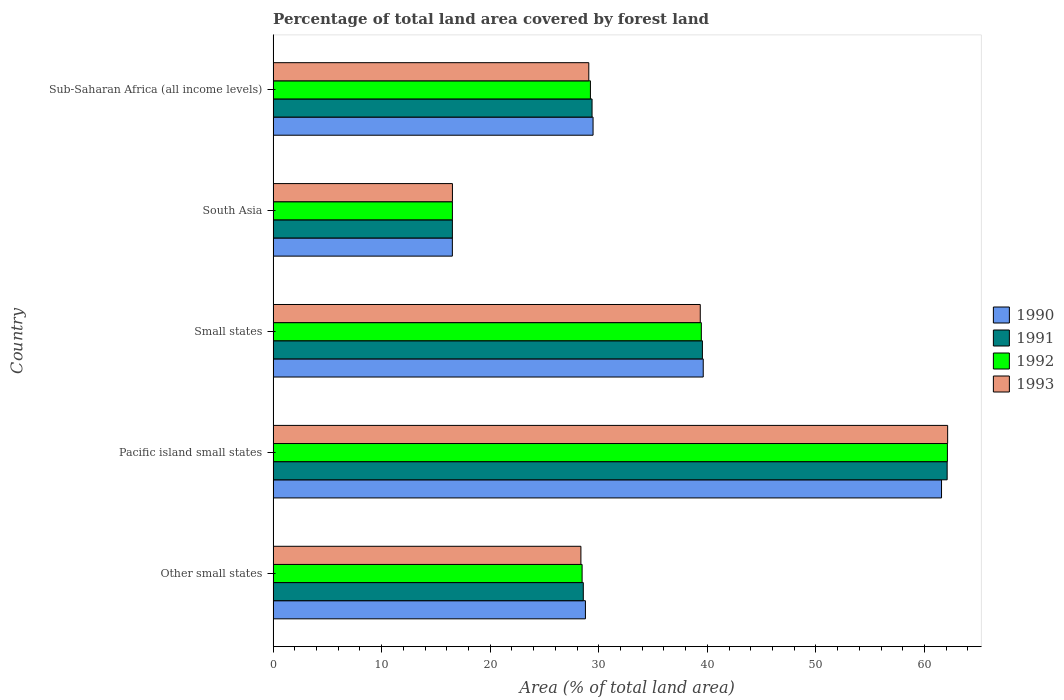Are the number of bars on each tick of the Y-axis equal?
Offer a very short reply. Yes. How many bars are there on the 2nd tick from the top?
Keep it short and to the point. 4. What is the label of the 2nd group of bars from the top?
Provide a succinct answer. South Asia. In how many cases, is the number of bars for a given country not equal to the number of legend labels?
Your response must be concise. 0. What is the percentage of forest land in 1993 in Sub-Saharan Africa (all income levels)?
Your answer should be compact. 29.08. Across all countries, what is the maximum percentage of forest land in 1993?
Ensure brevity in your answer.  62.13. Across all countries, what is the minimum percentage of forest land in 1990?
Ensure brevity in your answer.  16.51. In which country was the percentage of forest land in 1992 maximum?
Provide a succinct answer. Pacific island small states. In which country was the percentage of forest land in 1993 minimum?
Offer a very short reply. South Asia. What is the total percentage of forest land in 1991 in the graph?
Your answer should be compact. 176.1. What is the difference between the percentage of forest land in 1991 in South Asia and that in Sub-Saharan Africa (all income levels)?
Your response must be concise. -12.87. What is the difference between the percentage of forest land in 1992 in Sub-Saharan Africa (all income levels) and the percentage of forest land in 1991 in Small states?
Your answer should be very brief. -10.31. What is the average percentage of forest land in 1991 per country?
Provide a succinct answer. 35.22. What is the difference between the percentage of forest land in 1993 and percentage of forest land in 1992 in Small states?
Keep it short and to the point. -0.1. What is the ratio of the percentage of forest land in 1990 in Pacific island small states to that in Sub-Saharan Africa (all income levels)?
Offer a terse response. 2.09. Is the difference between the percentage of forest land in 1993 in Small states and Sub-Saharan Africa (all income levels) greater than the difference between the percentage of forest land in 1992 in Small states and Sub-Saharan Africa (all income levels)?
Your answer should be very brief. Yes. What is the difference between the highest and the second highest percentage of forest land in 1990?
Your response must be concise. 21.95. What is the difference between the highest and the lowest percentage of forest land in 1991?
Ensure brevity in your answer.  45.58. In how many countries, is the percentage of forest land in 1990 greater than the average percentage of forest land in 1990 taken over all countries?
Keep it short and to the point. 2. Is the sum of the percentage of forest land in 1991 in Other small states and Sub-Saharan Africa (all income levels) greater than the maximum percentage of forest land in 1992 across all countries?
Keep it short and to the point. No. What does the 3rd bar from the top in Small states represents?
Give a very brief answer. 1991. What does the 2nd bar from the bottom in Small states represents?
Ensure brevity in your answer.  1991. Is it the case that in every country, the sum of the percentage of forest land in 1992 and percentage of forest land in 1991 is greater than the percentage of forest land in 1993?
Your response must be concise. Yes. What is the difference between two consecutive major ticks on the X-axis?
Ensure brevity in your answer.  10. How are the legend labels stacked?
Give a very brief answer. Vertical. What is the title of the graph?
Give a very brief answer. Percentage of total land area covered by forest land. What is the label or title of the X-axis?
Ensure brevity in your answer.  Area (% of total land area). What is the Area (% of total land area) in 1990 in Other small states?
Offer a very short reply. 28.77. What is the Area (% of total land area) in 1991 in Other small states?
Offer a very short reply. 28.57. What is the Area (% of total land area) of 1992 in Other small states?
Make the answer very short. 28.46. What is the Area (% of total land area) of 1993 in Other small states?
Offer a very short reply. 28.35. What is the Area (% of total land area) in 1990 in Pacific island small states?
Keep it short and to the point. 61.57. What is the Area (% of total land area) in 1991 in Pacific island small states?
Offer a terse response. 62.09. What is the Area (% of total land area) of 1992 in Pacific island small states?
Your answer should be very brief. 62.11. What is the Area (% of total land area) in 1993 in Pacific island small states?
Keep it short and to the point. 62.13. What is the Area (% of total land area) of 1990 in Small states?
Provide a succinct answer. 39.62. What is the Area (% of total land area) of 1991 in Small states?
Your answer should be very brief. 39.54. What is the Area (% of total land area) of 1992 in Small states?
Give a very brief answer. 39.44. What is the Area (% of total land area) of 1993 in Small states?
Give a very brief answer. 39.35. What is the Area (% of total land area) of 1990 in South Asia?
Make the answer very short. 16.51. What is the Area (% of total land area) of 1991 in South Asia?
Ensure brevity in your answer.  16.51. What is the Area (% of total land area) of 1992 in South Asia?
Your response must be concise. 16.52. What is the Area (% of total land area) in 1993 in South Asia?
Your answer should be compact. 16.52. What is the Area (% of total land area) of 1990 in Sub-Saharan Africa (all income levels)?
Your response must be concise. 29.47. What is the Area (% of total land area) in 1991 in Sub-Saharan Africa (all income levels)?
Make the answer very short. 29.38. What is the Area (% of total land area) in 1992 in Sub-Saharan Africa (all income levels)?
Keep it short and to the point. 29.23. What is the Area (% of total land area) in 1993 in Sub-Saharan Africa (all income levels)?
Provide a succinct answer. 29.08. Across all countries, what is the maximum Area (% of total land area) of 1990?
Your answer should be very brief. 61.57. Across all countries, what is the maximum Area (% of total land area) in 1991?
Your answer should be very brief. 62.09. Across all countries, what is the maximum Area (% of total land area) of 1992?
Offer a very short reply. 62.11. Across all countries, what is the maximum Area (% of total land area) in 1993?
Offer a very short reply. 62.13. Across all countries, what is the minimum Area (% of total land area) in 1990?
Provide a short and direct response. 16.51. Across all countries, what is the minimum Area (% of total land area) in 1991?
Offer a very short reply. 16.51. Across all countries, what is the minimum Area (% of total land area) of 1992?
Ensure brevity in your answer.  16.52. Across all countries, what is the minimum Area (% of total land area) in 1993?
Provide a succinct answer. 16.52. What is the total Area (% of total land area) of 1990 in the graph?
Ensure brevity in your answer.  175.94. What is the total Area (% of total land area) in 1991 in the graph?
Provide a short and direct response. 176.1. What is the total Area (% of total land area) in 1992 in the graph?
Offer a very short reply. 175.76. What is the total Area (% of total land area) of 1993 in the graph?
Your response must be concise. 175.43. What is the difference between the Area (% of total land area) in 1990 in Other small states and that in Pacific island small states?
Your answer should be very brief. -32.8. What is the difference between the Area (% of total land area) in 1991 in Other small states and that in Pacific island small states?
Provide a short and direct response. -33.52. What is the difference between the Area (% of total land area) of 1992 in Other small states and that in Pacific island small states?
Provide a succinct answer. -33.65. What is the difference between the Area (% of total land area) in 1993 in Other small states and that in Pacific island small states?
Provide a short and direct response. -33.78. What is the difference between the Area (% of total land area) of 1990 in Other small states and that in Small states?
Provide a succinct answer. -10.85. What is the difference between the Area (% of total land area) of 1991 in Other small states and that in Small states?
Ensure brevity in your answer.  -10.97. What is the difference between the Area (% of total land area) in 1992 in Other small states and that in Small states?
Offer a very short reply. -10.98. What is the difference between the Area (% of total land area) in 1993 in Other small states and that in Small states?
Your answer should be compact. -11. What is the difference between the Area (% of total land area) in 1990 in Other small states and that in South Asia?
Your response must be concise. 12.26. What is the difference between the Area (% of total land area) in 1991 in Other small states and that in South Asia?
Make the answer very short. 12.06. What is the difference between the Area (% of total land area) in 1992 in Other small states and that in South Asia?
Keep it short and to the point. 11.95. What is the difference between the Area (% of total land area) in 1993 in Other small states and that in South Asia?
Ensure brevity in your answer.  11.83. What is the difference between the Area (% of total land area) of 1990 in Other small states and that in Sub-Saharan Africa (all income levels)?
Your answer should be very brief. -0.7. What is the difference between the Area (% of total land area) of 1991 in Other small states and that in Sub-Saharan Africa (all income levels)?
Offer a terse response. -0.81. What is the difference between the Area (% of total land area) in 1992 in Other small states and that in Sub-Saharan Africa (all income levels)?
Your response must be concise. -0.77. What is the difference between the Area (% of total land area) of 1993 in Other small states and that in Sub-Saharan Africa (all income levels)?
Your answer should be compact. -0.73. What is the difference between the Area (% of total land area) of 1990 in Pacific island small states and that in Small states?
Your answer should be compact. 21.95. What is the difference between the Area (% of total land area) of 1991 in Pacific island small states and that in Small states?
Give a very brief answer. 22.55. What is the difference between the Area (% of total land area) in 1992 in Pacific island small states and that in Small states?
Ensure brevity in your answer.  22.67. What is the difference between the Area (% of total land area) in 1993 in Pacific island small states and that in Small states?
Provide a succinct answer. 22.79. What is the difference between the Area (% of total land area) in 1990 in Pacific island small states and that in South Asia?
Provide a short and direct response. 45.06. What is the difference between the Area (% of total land area) of 1991 in Pacific island small states and that in South Asia?
Provide a succinct answer. 45.58. What is the difference between the Area (% of total land area) of 1992 in Pacific island small states and that in South Asia?
Your answer should be very brief. 45.6. What is the difference between the Area (% of total land area) of 1993 in Pacific island small states and that in South Asia?
Your answer should be very brief. 45.62. What is the difference between the Area (% of total land area) of 1990 in Pacific island small states and that in Sub-Saharan Africa (all income levels)?
Make the answer very short. 32.1. What is the difference between the Area (% of total land area) in 1991 in Pacific island small states and that in Sub-Saharan Africa (all income levels)?
Offer a terse response. 32.71. What is the difference between the Area (% of total land area) in 1992 in Pacific island small states and that in Sub-Saharan Africa (all income levels)?
Your answer should be very brief. 32.88. What is the difference between the Area (% of total land area) in 1993 in Pacific island small states and that in Sub-Saharan Africa (all income levels)?
Your response must be concise. 33.06. What is the difference between the Area (% of total land area) of 1990 in Small states and that in South Asia?
Your response must be concise. 23.11. What is the difference between the Area (% of total land area) of 1991 in Small states and that in South Asia?
Ensure brevity in your answer.  23.03. What is the difference between the Area (% of total land area) of 1992 in Small states and that in South Asia?
Ensure brevity in your answer.  22.93. What is the difference between the Area (% of total land area) in 1993 in Small states and that in South Asia?
Ensure brevity in your answer.  22.83. What is the difference between the Area (% of total land area) in 1990 in Small states and that in Sub-Saharan Africa (all income levels)?
Make the answer very short. 10.15. What is the difference between the Area (% of total land area) in 1991 in Small states and that in Sub-Saharan Africa (all income levels)?
Keep it short and to the point. 10.16. What is the difference between the Area (% of total land area) of 1992 in Small states and that in Sub-Saharan Africa (all income levels)?
Your answer should be very brief. 10.22. What is the difference between the Area (% of total land area) of 1993 in Small states and that in Sub-Saharan Africa (all income levels)?
Your answer should be very brief. 10.27. What is the difference between the Area (% of total land area) in 1990 in South Asia and that in Sub-Saharan Africa (all income levels)?
Ensure brevity in your answer.  -12.96. What is the difference between the Area (% of total land area) in 1991 in South Asia and that in Sub-Saharan Africa (all income levels)?
Provide a succinct answer. -12.87. What is the difference between the Area (% of total land area) of 1992 in South Asia and that in Sub-Saharan Africa (all income levels)?
Ensure brevity in your answer.  -12.71. What is the difference between the Area (% of total land area) of 1993 in South Asia and that in Sub-Saharan Africa (all income levels)?
Offer a very short reply. -12.56. What is the difference between the Area (% of total land area) of 1990 in Other small states and the Area (% of total land area) of 1991 in Pacific island small states?
Make the answer very short. -33.32. What is the difference between the Area (% of total land area) of 1990 in Other small states and the Area (% of total land area) of 1992 in Pacific island small states?
Make the answer very short. -33.34. What is the difference between the Area (% of total land area) of 1990 in Other small states and the Area (% of total land area) of 1993 in Pacific island small states?
Your response must be concise. -33.37. What is the difference between the Area (% of total land area) in 1991 in Other small states and the Area (% of total land area) in 1992 in Pacific island small states?
Make the answer very short. -33.54. What is the difference between the Area (% of total land area) of 1991 in Other small states and the Area (% of total land area) of 1993 in Pacific island small states?
Offer a very short reply. -33.56. What is the difference between the Area (% of total land area) in 1992 in Other small states and the Area (% of total land area) in 1993 in Pacific island small states?
Keep it short and to the point. -33.67. What is the difference between the Area (% of total land area) of 1990 in Other small states and the Area (% of total land area) of 1991 in Small states?
Your answer should be compact. -10.78. What is the difference between the Area (% of total land area) in 1990 in Other small states and the Area (% of total land area) in 1992 in Small states?
Your answer should be very brief. -10.68. What is the difference between the Area (% of total land area) in 1990 in Other small states and the Area (% of total land area) in 1993 in Small states?
Offer a terse response. -10.58. What is the difference between the Area (% of total land area) of 1991 in Other small states and the Area (% of total land area) of 1992 in Small states?
Offer a terse response. -10.87. What is the difference between the Area (% of total land area) of 1991 in Other small states and the Area (% of total land area) of 1993 in Small states?
Give a very brief answer. -10.77. What is the difference between the Area (% of total land area) of 1992 in Other small states and the Area (% of total land area) of 1993 in Small states?
Provide a succinct answer. -10.88. What is the difference between the Area (% of total land area) in 1990 in Other small states and the Area (% of total land area) in 1991 in South Asia?
Make the answer very short. 12.25. What is the difference between the Area (% of total land area) of 1990 in Other small states and the Area (% of total land area) of 1992 in South Asia?
Offer a very short reply. 12.25. What is the difference between the Area (% of total land area) of 1990 in Other small states and the Area (% of total land area) of 1993 in South Asia?
Your answer should be very brief. 12.25. What is the difference between the Area (% of total land area) of 1991 in Other small states and the Area (% of total land area) of 1992 in South Asia?
Ensure brevity in your answer.  12.06. What is the difference between the Area (% of total land area) in 1991 in Other small states and the Area (% of total land area) in 1993 in South Asia?
Ensure brevity in your answer.  12.05. What is the difference between the Area (% of total land area) in 1992 in Other small states and the Area (% of total land area) in 1993 in South Asia?
Ensure brevity in your answer.  11.94. What is the difference between the Area (% of total land area) of 1990 in Other small states and the Area (% of total land area) of 1991 in Sub-Saharan Africa (all income levels)?
Provide a succinct answer. -0.61. What is the difference between the Area (% of total land area) in 1990 in Other small states and the Area (% of total land area) in 1992 in Sub-Saharan Africa (all income levels)?
Your response must be concise. -0.46. What is the difference between the Area (% of total land area) of 1990 in Other small states and the Area (% of total land area) of 1993 in Sub-Saharan Africa (all income levels)?
Provide a short and direct response. -0.31. What is the difference between the Area (% of total land area) of 1991 in Other small states and the Area (% of total land area) of 1992 in Sub-Saharan Africa (all income levels)?
Ensure brevity in your answer.  -0.66. What is the difference between the Area (% of total land area) in 1991 in Other small states and the Area (% of total land area) in 1993 in Sub-Saharan Africa (all income levels)?
Give a very brief answer. -0.51. What is the difference between the Area (% of total land area) in 1992 in Other small states and the Area (% of total land area) in 1993 in Sub-Saharan Africa (all income levels)?
Offer a terse response. -0.62. What is the difference between the Area (% of total land area) of 1990 in Pacific island small states and the Area (% of total land area) of 1991 in Small states?
Give a very brief answer. 22.03. What is the difference between the Area (% of total land area) of 1990 in Pacific island small states and the Area (% of total land area) of 1992 in Small states?
Your answer should be very brief. 22.13. What is the difference between the Area (% of total land area) of 1990 in Pacific island small states and the Area (% of total land area) of 1993 in Small states?
Provide a short and direct response. 22.22. What is the difference between the Area (% of total land area) in 1991 in Pacific island small states and the Area (% of total land area) in 1992 in Small states?
Your answer should be compact. 22.64. What is the difference between the Area (% of total land area) in 1991 in Pacific island small states and the Area (% of total land area) in 1993 in Small states?
Make the answer very short. 22.74. What is the difference between the Area (% of total land area) in 1992 in Pacific island small states and the Area (% of total land area) in 1993 in Small states?
Your answer should be compact. 22.76. What is the difference between the Area (% of total land area) in 1990 in Pacific island small states and the Area (% of total land area) in 1991 in South Asia?
Ensure brevity in your answer.  45.06. What is the difference between the Area (% of total land area) of 1990 in Pacific island small states and the Area (% of total land area) of 1992 in South Asia?
Your response must be concise. 45.05. What is the difference between the Area (% of total land area) of 1990 in Pacific island small states and the Area (% of total land area) of 1993 in South Asia?
Offer a very short reply. 45.05. What is the difference between the Area (% of total land area) of 1991 in Pacific island small states and the Area (% of total land area) of 1992 in South Asia?
Keep it short and to the point. 45.57. What is the difference between the Area (% of total land area) in 1991 in Pacific island small states and the Area (% of total land area) in 1993 in South Asia?
Ensure brevity in your answer.  45.57. What is the difference between the Area (% of total land area) of 1992 in Pacific island small states and the Area (% of total land area) of 1993 in South Asia?
Keep it short and to the point. 45.59. What is the difference between the Area (% of total land area) in 1990 in Pacific island small states and the Area (% of total land area) in 1991 in Sub-Saharan Africa (all income levels)?
Offer a very short reply. 32.19. What is the difference between the Area (% of total land area) of 1990 in Pacific island small states and the Area (% of total land area) of 1992 in Sub-Saharan Africa (all income levels)?
Keep it short and to the point. 32.34. What is the difference between the Area (% of total land area) of 1990 in Pacific island small states and the Area (% of total land area) of 1993 in Sub-Saharan Africa (all income levels)?
Keep it short and to the point. 32.49. What is the difference between the Area (% of total land area) in 1991 in Pacific island small states and the Area (% of total land area) in 1992 in Sub-Saharan Africa (all income levels)?
Your answer should be very brief. 32.86. What is the difference between the Area (% of total land area) of 1991 in Pacific island small states and the Area (% of total land area) of 1993 in Sub-Saharan Africa (all income levels)?
Give a very brief answer. 33.01. What is the difference between the Area (% of total land area) of 1992 in Pacific island small states and the Area (% of total land area) of 1993 in Sub-Saharan Africa (all income levels)?
Provide a succinct answer. 33.03. What is the difference between the Area (% of total land area) of 1990 in Small states and the Area (% of total land area) of 1991 in South Asia?
Offer a very short reply. 23.11. What is the difference between the Area (% of total land area) in 1990 in Small states and the Area (% of total land area) in 1992 in South Asia?
Your answer should be compact. 23.1. What is the difference between the Area (% of total land area) in 1990 in Small states and the Area (% of total land area) in 1993 in South Asia?
Offer a terse response. 23.1. What is the difference between the Area (% of total land area) of 1991 in Small states and the Area (% of total land area) of 1992 in South Asia?
Ensure brevity in your answer.  23.03. What is the difference between the Area (% of total land area) in 1991 in Small states and the Area (% of total land area) in 1993 in South Asia?
Your answer should be compact. 23.03. What is the difference between the Area (% of total land area) in 1992 in Small states and the Area (% of total land area) in 1993 in South Asia?
Provide a short and direct response. 22.93. What is the difference between the Area (% of total land area) of 1990 in Small states and the Area (% of total land area) of 1991 in Sub-Saharan Africa (all income levels)?
Give a very brief answer. 10.24. What is the difference between the Area (% of total land area) in 1990 in Small states and the Area (% of total land area) in 1992 in Sub-Saharan Africa (all income levels)?
Offer a terse response. 10.39. What is the difference between the Area (% of total land area) of 1990 in Small states and the Area (% of total land area) of 1993 in Sub-Saharan Africa (all income levels)?
Provide a succinct answer. 10.54. What is the difference between the Area (% of total land area) in 1991 in Small states and the Area (% of total land area) in 1992 in Sub-Saharan Africa (all income levels)?
Ensure brevity in your answer.  10.31. What is the difference between the Area (% of total land area) of 1991 in Small states and the Area (% of total land area) of 1993 in Sub-Saharan Africa (all income levels)?
Your response must be concise. 10.46. What is the difference between the Area (% of total land area) of 1992 in Small states and the Area (% of total land area) of 1993 in Sub-Saharan Africa (all income levels)?
Your answer should be very brief. 10.37. What is the difference between the Area (% of total land area) in 1990 in South Asia and the Area (% of total land area) in 1991 in Sub-Saharan Africa (all income levels)?
Provide a short and direct response. -12.87. What is the difference between the Area (% of total land area) of 1990 in South Asia and the Area (% of total land area) of 1992 in Sub-Saharan Africa (all income levels)?
Make the answer very short. -12.72. What is the difference between the Area (% of total land area) in 1990 in South Asia and the Area (% of total land area) in 1993 in Sub-Saharan Africa (all income levels)?
Provide a short and direct response. -12.57. What is the difference between the Area (% of total land area) in 1991 in South Asia and the Area (% of total land area) in 1992 in Sub-Saharan Africa (all income levels)?
Offer a very short reply. -12.72. What is the difference between the Area (% of total land area) in 1991 in South Asia and the Area (% of total land area) in 1993 in Sub-Saharan Africa (all income levels)?
Make the answer very short. -12.56. What is the difference between the Area (% of total land area) in 1992 in South Asia and the Area (% of total land area) in 1993 in Sub-Saharan Africa (all income levels)?
Keep it short and to the point. -12.56. What is the average Area (% of total land area) of 1990 per country?
Your answer should be very brief. 35.19. What is the average Area (% of total land area) in 1991 per country?
Provide a short and direct response. 35.22. What is the average Area (% of total land area) in 1992 per country?
Offer a terse response. 35.15. What is the average Area (% of total land area) of 1993 per country?
Give a very brief answer. 35.09. What is the difference between the Area (% of total land area) in 1990 and Area (% of total land area) in 1991 in Other small states?
Provide a short and direct response. 0.19. What is the difference between the Area (% of total land area) in 1990 and Area (% of total land area) in 1992 in Other small states?
Give a very brief answer. 0.31. What is the difference between the Area (% of total land area) of 1990 and Area (% of total land area) of 1993 in Other small states?
Offer a very short reply. 0.42. What is the difference between the Area (% of total land area) of 1991 and Area (% of total land area) of 1992 in Other small states?
Your answer should be compact. 0.11. What is the difference between the Area (% of total land area) of 1991 and Area (% of total land area) of 1993 in Other small states?
Ensure brevity in your answer.  0.22. What is the difference between the Area (% of total land area) of 1992 and Area (% of total land area) of 1993 in Other small states?
Ensure brevity in your answer.  0.11. What is the difference between the Area (% of total land area) in 1990 and Area (% of total land area) in 1991 in Pacific island small states?
Offer a very short reply. -0.52. What is the difference between the Area (% of total land area) in 1990 and Area (% of total land area) in 1992 in Pacific island small states?
Keep it short and to the point. -0.54. What is the difference between the Area (% of total land area) of 1990 and Area (% of total land area) of 1993 in Pacific island small states?
Ensure brevity in your answer.  -0.56. What is the difference between the Area (% of total land area) in 1991 and Area (% of total land area) in 1992 in Pacific island small states?
Provide a short and direct response. -0.02. What is the difference between the Area (% of total land area) of 1991 and Area (% of total land area) of 1993 in Pacific island small states?
Your answer should be compact. -0.04. What is the difference between the Area (% of total land area) in 1992 and Area (% of total land area) in 1993 in Pacific island small states?
Your answer should be compact. -0.02. What is the difference between the Area (% of total land area) of 1990 and Area (% of total land area) of 1991 in Small states?
Offer a very short reply. 0.08. What is the difference between the Area (% of total land area) in 1990 and Area (% of total land area) in 1992 in Small states?
Give a very brief answer. 0.17. What is the difference between the Area (% of total land area) of 1990 and Area (% of total land area) of 1993 in Small states?
Your answer should be compact. 0.27. What is the difference between the Area (% of total land area) of 1991 and Area (% of total land area) of 1992 in Small states?
Provide a short and direct response. 0.1. What is the difference between the Area (% of total land area) of 1991 and Area (% of total land area) of 1993 in Small states?
Keep it short and to the point. 0.2. What is the difference between the Area (% of total land area) of 1992 and Area (% of total land area) of 1993 in Small states?
Offer a terse response. 0.1. What is the difference between the Area (% of total land area) in 1990 and Area (% of total land area) in 1991 in South Asia?
Your answer should be very brief. -0. What is the difference between the Area (% of total land area) in 1990 and Area (% of total land area) in 1992 in South Asia?
Your answer should be very brief. -0. What is the difference between the Area (% of total land area) of 1990 and Area (% of total land area) of 1993 in South Asia?
Offer a terse response. -0.01. What is the difference between the Area (% of total land area) of 1991 and Area (% of total land area) of 1992 in South Asia?
Your answer should be compact. -0. What is the difference between the Area (% of total land area) in 1991 and Area (% of total land area) in 1993 in South Asia?
Keep it short and to the point. -0. What is the difference between the Area (% of total land area) of 1992 and Area (% of total land area) of 1993 in South Asia?
Offer a very short reply. -0. What is the difference between the Area (% of total land area) in 1990 and Area (% of total land area) in 1991 in Sub-Saharan Africa (all income levels)?
Make the answer very short. 0.09. What is the difference between the Area (% of total land area) of 1990 and Area (% of total land area) of 1992 in Sub-Saharan Africa (all income levels)?
Provide a short and direct response. 0.24. What is the difference between the Area (% of total land area) in 1990 and Area (% of total land area) in 1993 in Sub-Saharan Africa (all income levels)?
Offer a terse response. 0.39. What is the difference between the Area (% of total land area) of 1991 and Area (% of total land area) of 1992 in Sub-Saharan Africa (all income levels)?
Your response must be concise. 0.15. What is the difference between the Area (% of total land area) in 1991 and Area (% of total land area) in 1993 in Sub-Saharan Africa (all income levels)?
Your answer should be compact. 0.3. What is the difference between the Area (% of total land area) of 1992 and Area (% of total land area) of 1993 in Sub-Saharan Africa (all income levels)?
Keep it short and to the point. 0.15. What is the ratio of the Area (% of total land area) in 1990 in Other small states to that in Pacific island small states?
Give a very brief answer. 0.47. What is the ratio of the Area (% of total land area) of 1991 in Other small states to that in Pacific island small states?
Your answer should be very brief. 0.46. What is the ratio of the Area (% of total land area) of 1992 in Other small states to that in Pacific island small states?
Provide a succinct answer. 0.46. What is the ratio of the Area (% of total land area) in 1993 in Other small states to that in Pacific island small states?
Your answer should be compact. 0.46. What is the ratio of the Area (% of total land area) in 1990 in Other small states to that in Small states?
Keep it short and to the point. 0.73. What is the ratio of the Area (% of total land area) of 1991 in Other small states to that in Small states?
Your answer should be compact. 0.72. What is the ratio of the Area (% of total land area) of 1992 in Other small states to that in Small states?
Your answer should be very brief. 0.72. What is the ratio of the Area (% of total land area) of 1993 in Other small states to that in Small states?
Keep it short and to the point. 0.72. What is the ratio of the Area (% of total land area) in 1990 in Other small states to that in South Asia?
Provide a short and direct response. 1.74. What is the ratio of the Area (% of total land area) of 1991 in Other small states to that in South Asia?
Provide a succinct answer. 1.73. What is the ratio of the Area (% of total land area) in 1992 in Other small states to that in South Asia?
Keep it short and to the point. 1.72. What is the ratio of the Area (% of total land area) of 1993 in Other small states to that in South Asia?
Give a very brief answer. 1.72. What is the ratio of the Area (% of total land area) of 1990 in Other small states to that in Sub-Saharan Africa (all income levels)?
Offer a terse response. 0.98. What is the ratio of the Area (% of total land area) of 1991 in Other small states to that in Sub-Saharan Africa (all income levels)?
Offer a very short reply. 0.97. What is the ratio of the Area (% of total land area) of 1992 in Other small states to that in Sub-Saharan Africa (all income levels)?
Your answer should be very brief. 0.97. What is the ratio of the Area (% of total land area) in 1990 in Pacific island small states to that in Small states?
Ensure brevity in your answer.  1.55. What is the ratio of the Area (% of total land area) in 1991 in Pacific island small states to that in Small states?
Your response must be concise. 1.57. What is the ratio of the Area (% of total land area) in 1992 in Pacific island small states to that in Small states?
Provide a short and direct response. 1.57. What is the ratio of the Area (% of total land area) in 1993 in Pacific island small states to that in Small states?
Keep it short and to the point. 1.58. What is the ratio of the Area (% of total land area) of 1990 in Pacific island small states to that in South Asia?
Your answer should be very brief. 3.73. What is the ratio of the Area (% of total land area) in 1991 in Pacific island small states to that in South Asia?
Offer a very short reply. 3.76. What is the ratio of the Area (% of total land area) of 1992 in Pacific island small states to that in South Asia?
Offer a very short reply. 3.76. What is the ratio of the Area (% of total land area) in 1993 in Pacific island small states to that in South Asia?
Give a very brief answer. 3.76. What is the ratio of the Area (% of total land area) in 1990 in Pacific island small states to that in Sub-Saharan Africa (all income levels)?
Give a very brief answer. 2.09. What is the ratio of the Area (% of total land area) of 1991 in Pacific island small states to that in Sub-Saharan Africa (all income levels)?
Your response must be concise. 2.11. What is the ratio of the Area (% of total land area) of 1992 in Pacific island small states to that in Sub-Saharan Africa (all income levels)?
Offer a very short reply. 2.12. What is the ratio of the Area (% of total land area) in 1993 in Pacific island small states to that in Sub-Saharan Africa (all income levels)?
Your answer should be compact. 2.14. What is the ratio of the Area (% of total land area) of 1990 in Small states to that in South Asia?
Keep it short and to the point. 2.4. What is the ratio of the Area (% of total land area) of 1991 in Small states to that in South Asia?
Your response must be concise. 2.39. What is the ratio of the Area (% of total land area) in 1992 in Small states to that in South Asia?
Give a very brief answer. 2.39. What is the ratio of the Area (% of total land area) of 1993 in Small states to that in South Asia?
Offer a very short reply. 2.38. What is the ratio of the Area (% of total land area) of 1990 in Small states to that in Sub-Saharan Africa (all income levels)?
Your answer should be compact. 1.34. What is the ratio of the Area (% of total land area) of 1991 in Small states to that in Sub-Saharan Africa (all income levels)?
Offer a terse response. 1.35. What is the ratio of the Area (% of total land area) in 1992 in Small states to that in Sub-Saharan Africa (all income levels)?
Ensure brevity in your answer.  1.35. What is the ratio of the Area (% of total land area) of 1993 in Small states to that in Sub-Saharan Africa (all income levels)?
Provide a short and direct response. 1.35. What is the ratio of the Area (% of total land area) of 1990 in South Asia to that in Sub-Saharan Africa (all income levels)?
Give a very brief answer. 0.56. What is the ratio of the Area (% of total land area) in 1991 in South Asia to that in Sub-Saharan Africa (all income levels)?
Make the answer very short. 0.56. What is the ratio of the Area (% of total land area) of 1992 in South Asia to that in Sub-Saharan Africa (all income levels)?
Give a very brief answer. 0.56. What is the ratio of the Area (% of total land area) of 1993 in South Asia to that in Sub-Saharan Africa (all income levels)?
Your answer should be compact. 0.57. What is the difference between the highest and the second highest Area (% of total land area) in 1990?
Offer a terse response. 21.95. What is the difference between the highest and the second highest Area (% of total land area) of 1991?
Offer a very short reply. 22.55. What is the difference between the highest and the second highest Area (% of total land area) of 1992?
Provide a short and direct response. 22.67. What is the difference between the highest and the second highest Area (% of total land area) of 1993?
Your response must be concise. 22.79. What is the difference between the highest and the lowest Area (% of total land area) in 1990?
Your answer should be compact. 45.06. What is the difference between the highest and the lowest Area (% of total land area) in 1991?
Your response must be concise. 45.58. What is the difference between the highest and the lowest Area (% of total land area) of 1992?
Your answer should be very brief. 45.6. What is the difference between the highest and the lowest Area (% of total land area) of 1993?
Keep it short and to the point. 45.62. 